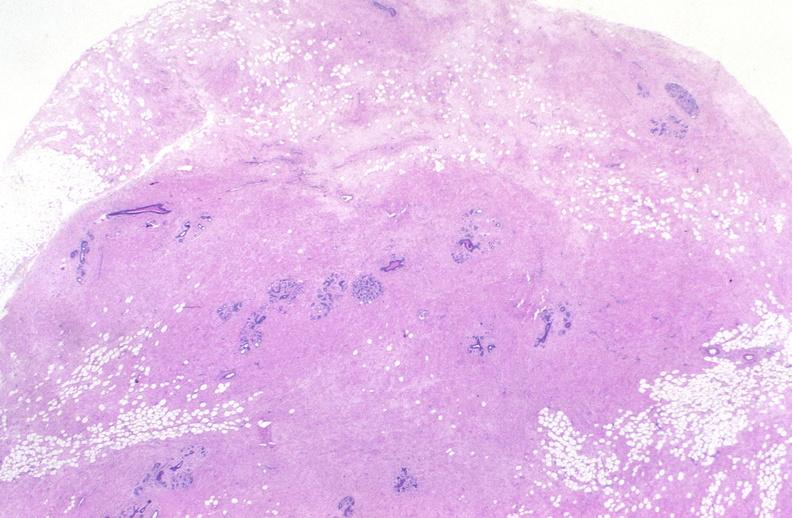does this image show breast, fibroadenoma?
Answer the question using a single word or phrase. Yes 